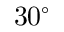Convert formula to latex. <formula><loc_0><loc_0><loc_500><loc_500>3 0 ^ { \circ }</formula> 